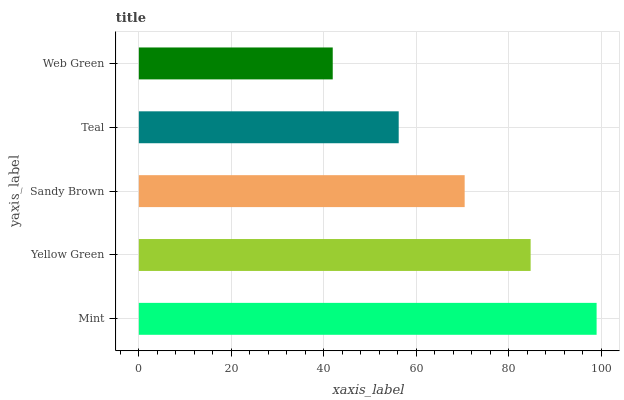Is Web Green the minimum?
Answer yes or no. Yes. Is Mint the maximum?
Answer yes or no. Yes. Is Yellow Green the minimum?
Answer yes or no. No. Is Yellow Green the maximum?
Answer yes or no. No. Is Mint greater than Yellow Green?
Answer yes or no. Yes. Is Yellow Green less than Mint?
Answer yes or no. Yes. Is Yellow Green greater than Mint?
Answer yes or no. No. Is Mint less than Yellow Green?
Answer yes or no. No. Is Sandy Brown the high median?
Answer yes or no. Yes. Is Sandy Brown the low median?
Answer yes or no. Yes. Is Teal the high median?
Answer yes or no. No. Is Web Green the low median?
Answer yes or no. No. 